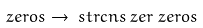Convert formula to latex. <formula><loc_0><loc_0><loc_500><loc_500>\ z e r o s & \to \ s t r c n s { \ z e r } { \ z e r o s }</formula> 